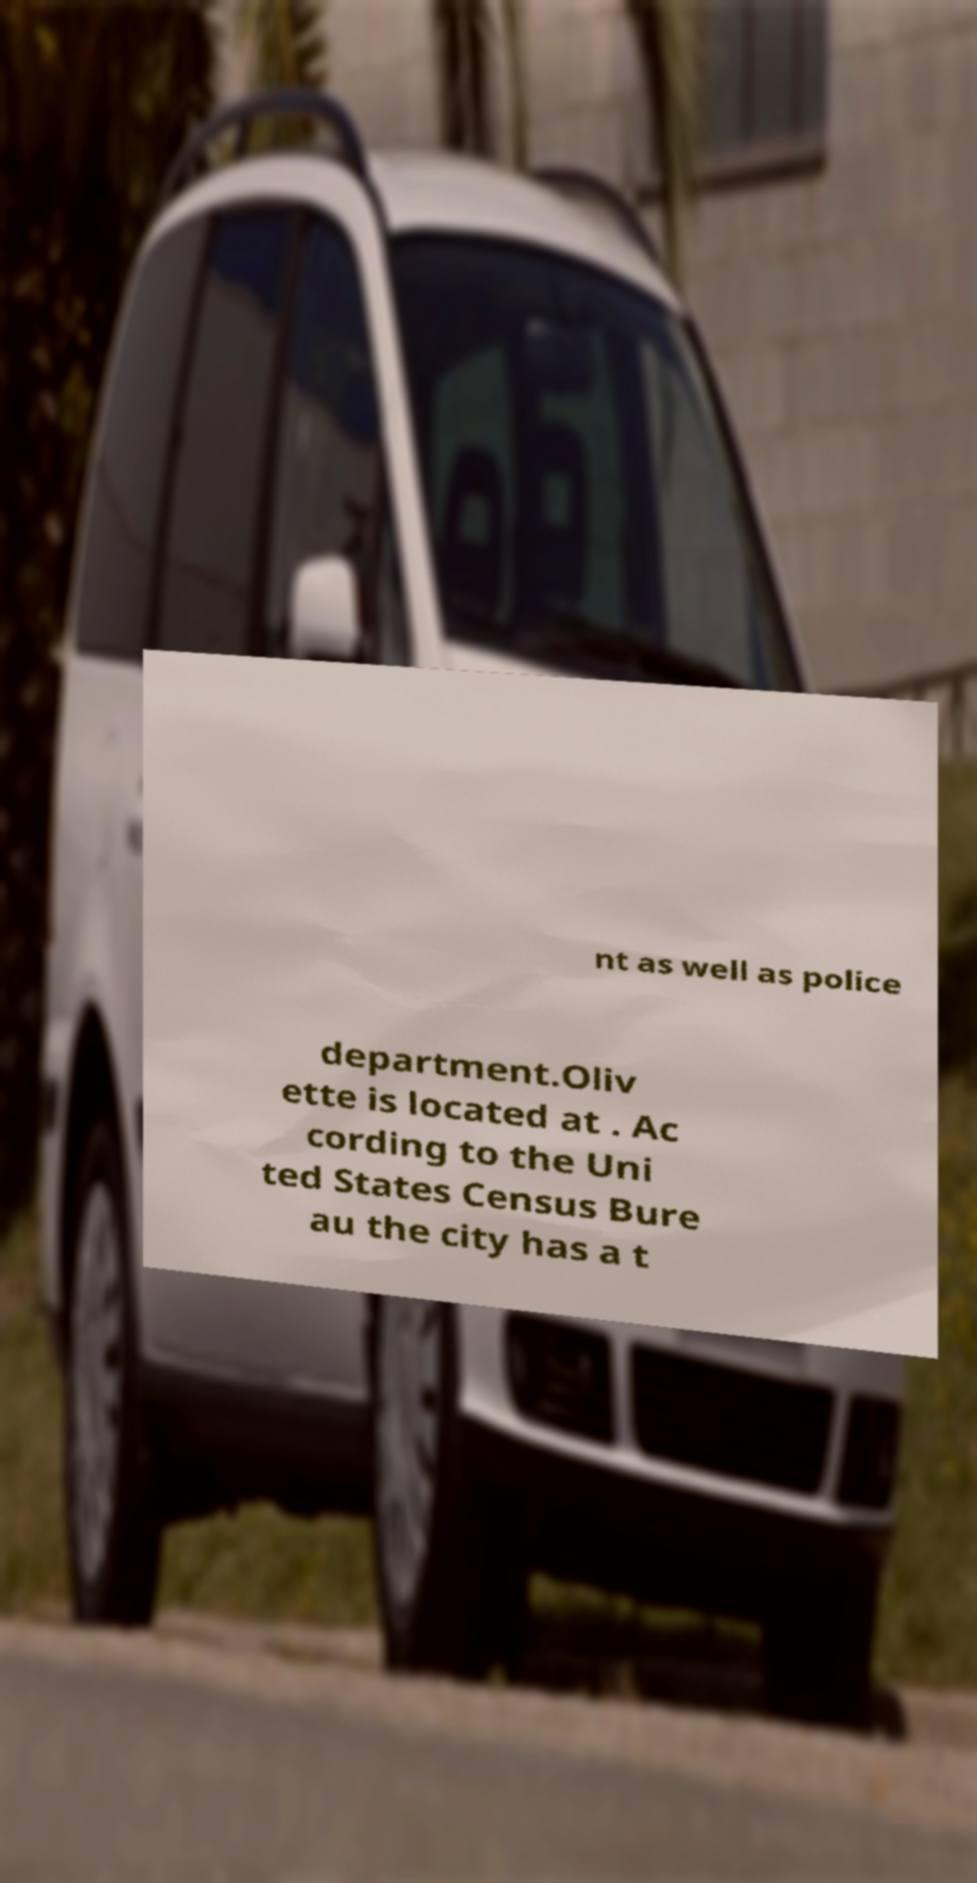For documentation purposes, I need the text within this image transcribed. Could you provide that? nt as well as police department.Oliv ette is located at . Ac cording to the Uni ted States Census Bure au the city has a t 